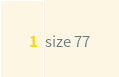<code> <loc_0><loc_0><loc_500><loc_500><_YAML_>size 77
</code> 